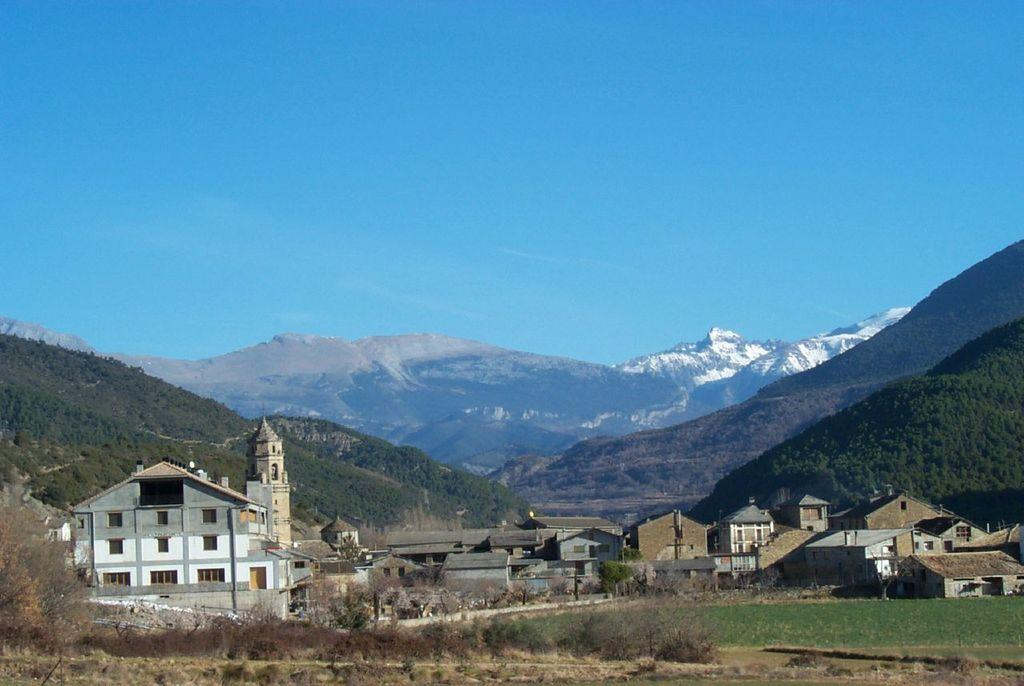What type of structures can be seen in the image? There are buildings in the image. What type of vegetation is present in the image? There are trees in the image. What type of open space is visible in the image? There is a field in the image. What can be seen in the distance in the image? There are mountains visible in the background of the image. What is visible above the buildings and trees in the image? The sky is visible in the background of the image. What type of book is being pushed around in the image? There is no book or pushing activity present in the image. What type of joke can be seen on the mountains in the image? There is no joke present in the image; the mountains are a natural feature in the background. 